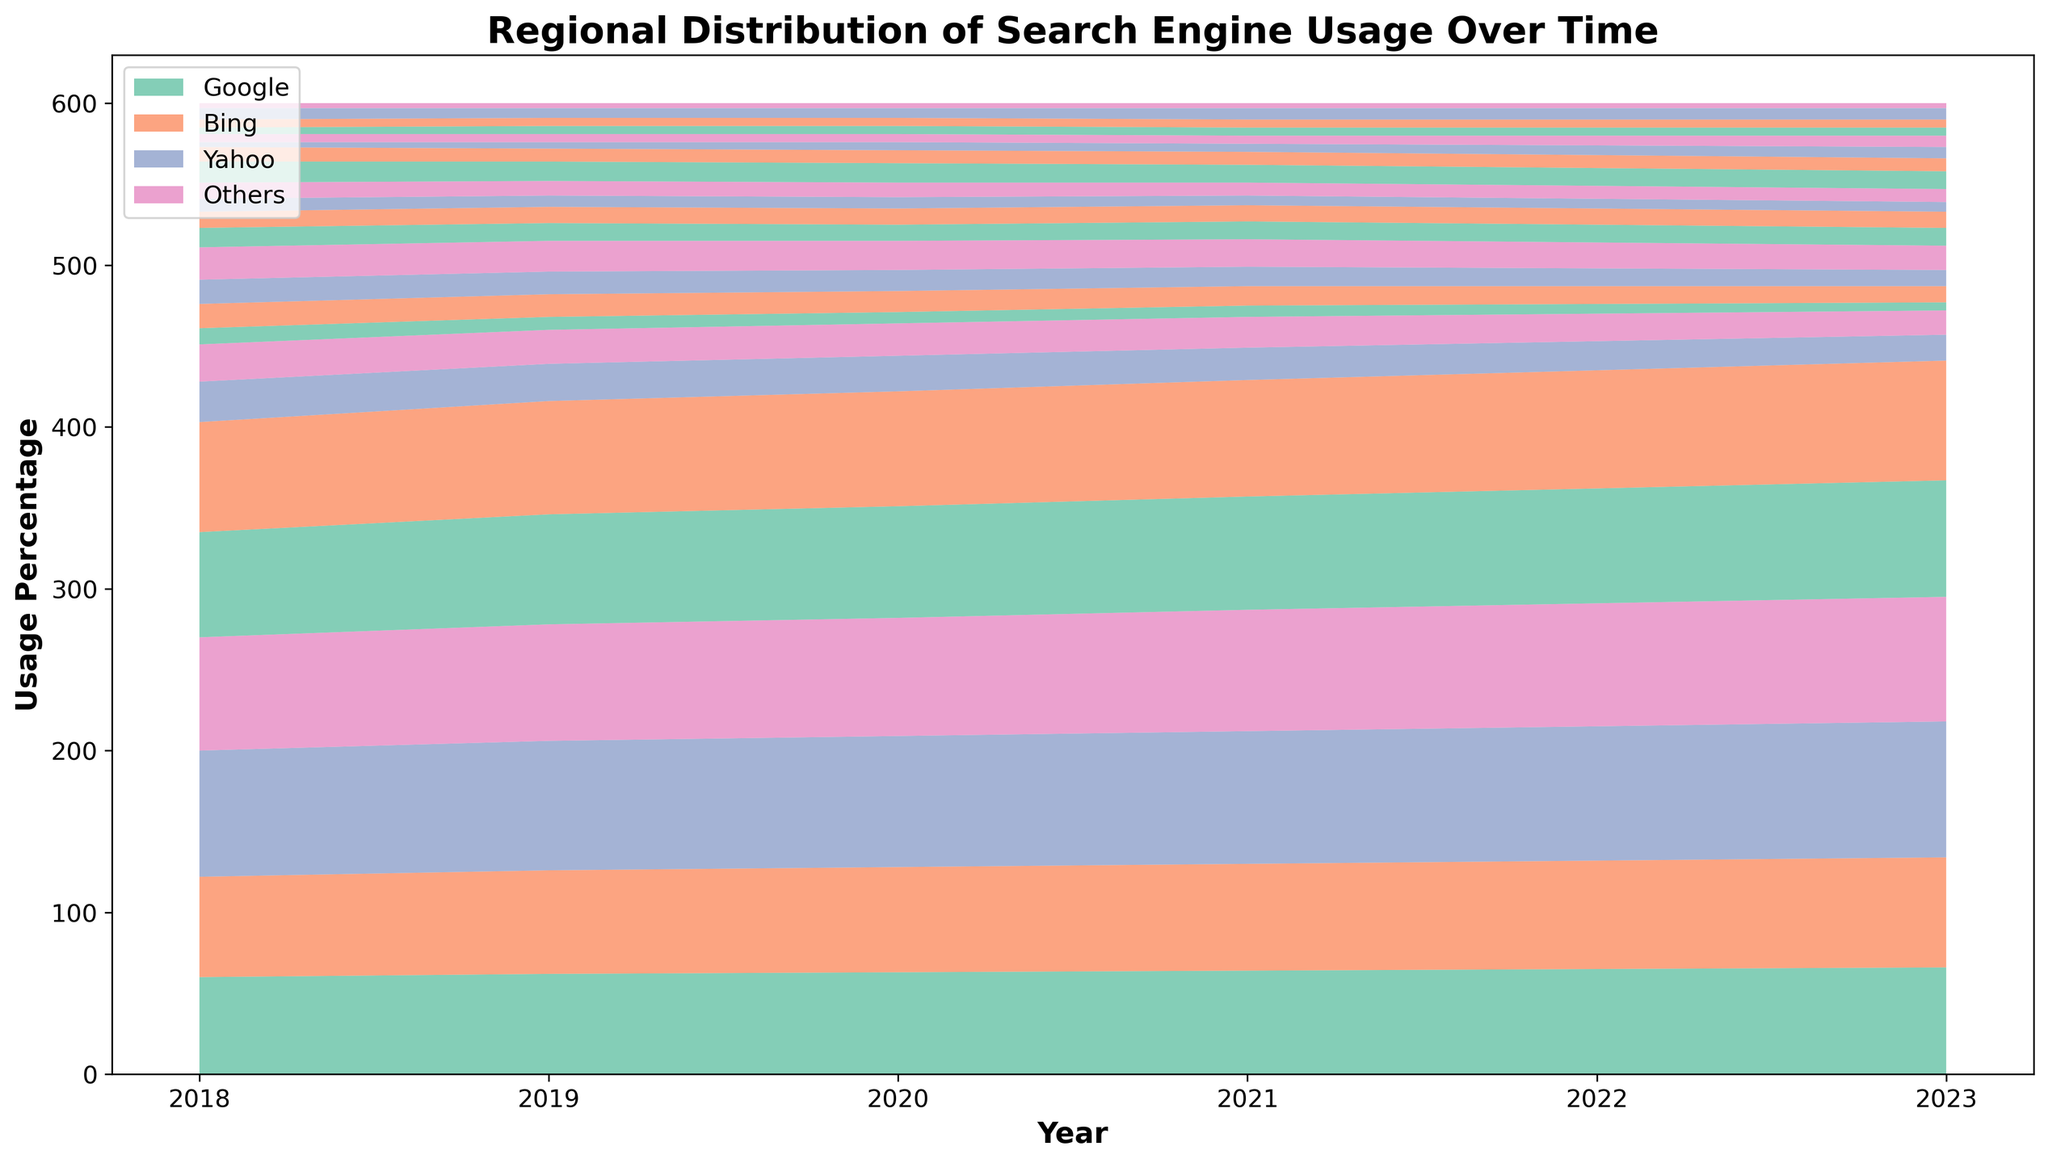Which search engine had the highest usage in Asia in 2020? The visual representation will show the layers, with the topmost layer indicating the highest percentage. For 2020 in Asia, Google is the topmost layer.
Answer: Google How did Bing's usage in Europe change from 2018 to 2023? By comparing the size of the Bing layer in Europe over the years. The Bing usage decreases from 23% in 2018 to 15% in 2023.
Answer: Decreased What is the trend of Yahoo's usage in Africa from 2018 to 2023? Look at the Yahoo layer in the Africa section for each year. It decreases from 13% in 2018 to 11% in 2023.
Answer: Decreasing Which region saw the highest increase in Google usage from 2018 to 2023? Compare the heights of the Google section across all regions from 2018 to 2023. Asia increased from 78% to 84%.
Answer: Asia In 2022, which region had the smallest 'Others' search engine usage? The 'Others' group is the bottom-most layer. Compare their sizes across regions in 2022. Australia, with 3%.
Answer: Australia How much did Google's usage increase in North America from 2018 to 2023? Compare Google's layer in North America for 2018 and 2023. The usage increased from 60% to 66%.
Answer: 6% In which year did Bing's usage in South America see the largest drop? Observe the Bing layer in South America over the years and identify the steepest decline. The biggest drop is from 2021 (12%) to 2022 (11%).
Answer: 2021 to 2022 What was the combined percentage of 'Others' in Europe and North America in 2023? Add the 'Others' percentages for Europe (7%) and North America (7%) in 2023.
Answer: 14% Which search engine consistently had the second highest usage in Australia across all years? Look at the layers and identify the second from the top for each year in Australia. Bing is consistently the second highest.
Answer: Bing What is the relative difference in Yahoo usage between 2018 and 2023 in Australia? Subtract the percentage of Yahoo usage in 2023 (8%) from 2018 (9%) and divide by the 2018 value. The relative difference is (9 - 8) / 9 = 1/9 or approximately 11.11%.
Answer: Approximately 11.11% 